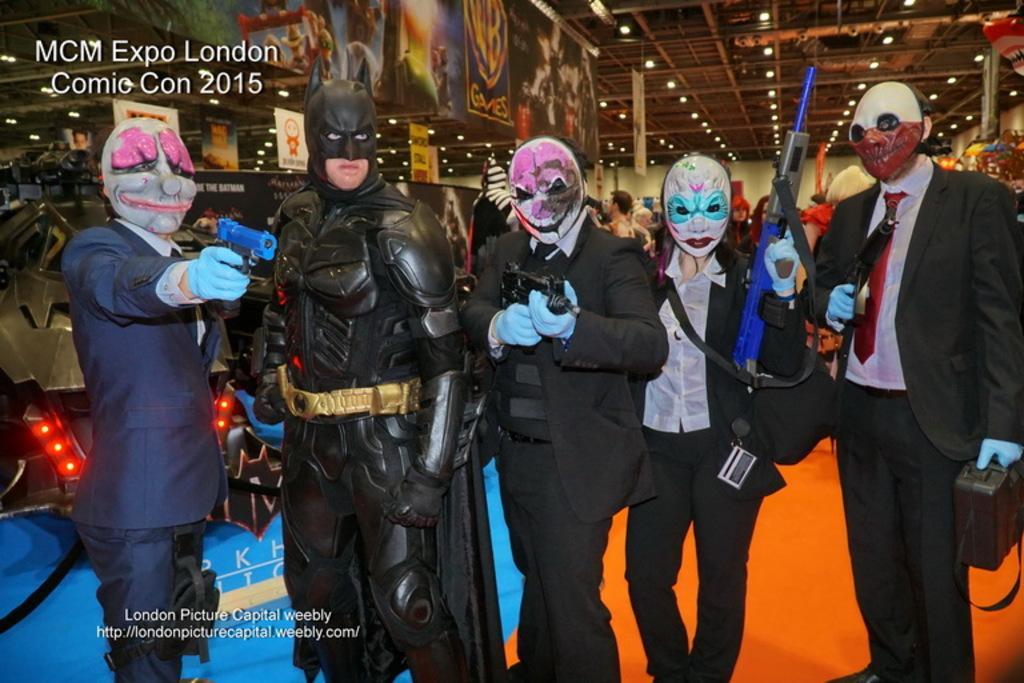How would you summarize this image in a sentence or two? In the picture there are five people standing in a line, they are wearing different costumes with the mask, behind there are many people present, there are banners present, there are lights present on the roof. 